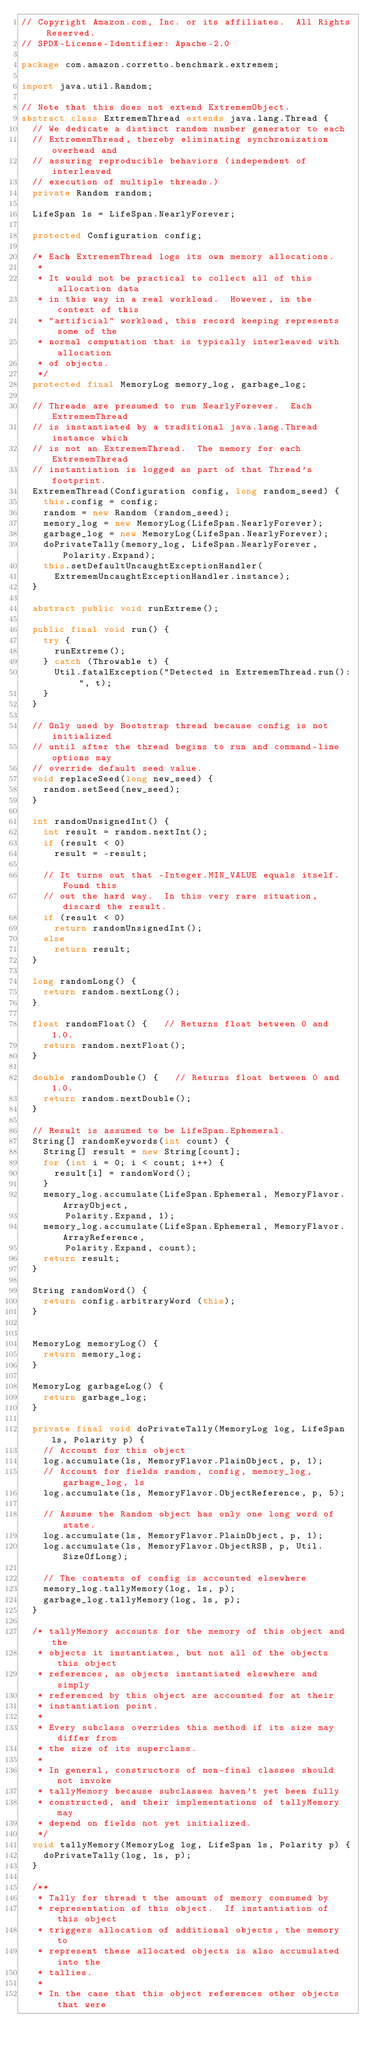Convert code to text. <code><loc_0><loc_0><loc_500><loc_500><_Java_>// Copyright Amazon.com, Inc. or its affiliates.  All Rights Reserved.
// SPDX-License-Identifier: Apache-2.0

package com.amazon.corretto.benchmark.extremem;

import java.util.Random;

// Note that this does not extend ExtrememObject.
abstract class ExtrememThread extends java.lang.Thread {
  // We dedicate a distinct random number generator to each
  // ExtrememThread, thereby eliminating synchronization overhead and
  // assuring reproducible behaviors (independent of interleaved
  // execution of multiple threads.)
  private Random random;

  LifeSpan ls = LifeSpan.NearlyForever;

  protected Configuration config;

  /* Each ExtrememThread logs its own memory allocations.
   *
   * It would not be practical to collect all of this allocation data
   * in this way in a real workload.  However, in the context of this
   * "artificial" workload, this record keeping represents some of the
   * normal computation that is typically interleaved with allocation
   * of objects.
   */
  protected final MemoryLog memory_log, garbage_log;

  // Threads are presumed to run NearlyForever.  Each ExtrememThread
  // is instantiated by a traditional java.lang.Thread instance which
  // is not an ExtrememThread.  The memory for each ExtrememThread
  // instantiation is logged as part of that Thread's footprint.
  ExtrememThread(Configuration config, long random_seed) {
    this.config = config;
    random = new Random (random_seed);
    memory_log = new MemoryLog(LifeSpan.NearlyForever);
    garbage_log = new MemoryLog(LifeSpan.NearlyForever);
    doPrivateTally(memory_log, LifeSpan.NearlyForever, Polarity.Expand);
    this.setDefaultUncaughtExceptionHandler(
      ExtrememUncaughtExceptionHandler.instance);
  }

  abstract public void runExtreme();

  public final void run() {
    try {
      runExtreme();
    } catch (Throwable t) {
      Util.fatalException("Detected in ExtrememThread.run(): ", t);
    }
  }

  // Only used by Bootstrap thread because config is not initialized
  // until after the thread begins to run and command-line options may
  // override default seed value.
  void replaceSeed(long new_seed) {
    random.setSeed(new_seed);
  }

  int randomUnsignedInt() {
    int result = random.nextInt();
    if (result < 0)
      result = -result;

    // It turns out that -Integer.MIN_VALUE equals itself.  Found this
    // out the hard way.  In this very rare situation, discard the result.
    if (result < 0)
      return randomUnsignedInt();
    else
      return result;
  }

  long randomLong() {
    return random.nextLong();
  }

  float randomFloat() {		// Returns float between 0 and 1.0.
    return random.nextFloat();
  }

  double randomDouble() {		// Returns float between 0 and 1.0.
    return random.nextDouble();
  }

  // Result is assumed to be LifeSpan.Ephemeral.
  String[] randomKeywords(int count) {
    String[] result = new String[count];
    for (int i = 0; i < count; i++) {
      result[i] = randomWord();
    }
    memory_log.accumulate(LifeSpan.Ephemeral, MemoryFlavor.ArrayObject,
			  Polarity.Expand, 1);
    memory_log.accumulate(LifeSpan.Ephemeral, MemoryFlavor.ArrayReference,
			  Polarity.Expand, count);
    return result;
  }

  String randomWord() {
    return config.arbitraryWord (this);
  }


  MemoryLog memoryLog() {
    return memory_log;
  }

  MemoryLog garbageLog() {
    return garbage_log;
  }

  private final void doPrivateTally(MemoryLog log, LifeSpan ls, Polarity p) {
    // Account for this object
    log.accumulate(ls, MemoryFlavor.PlainObject, p, 1);
    // Account for fields random, config, memory_log, garbage_log, ls
    log.accumulate(ls, MemoryFlavor.ObjectReference, p, 5);

    // Assume the Random object has only one long word of state.
    log.accumulate(ls, MemoryFlavor.PlainObject, p, 1);
    log.accumulate(ls, MemoryFlavor.ObjectRSB, p, Util.SizeOfLong);

    // The contents of config is accounted elsewhere
    memory_log.tallyMemory(log, ls, p);
    garbage_log.tallyMemory(log, ls, p);
  }

  /* tallyMemory accounts for the memory of this object and the
   * objects it instantiates, but not all of the objects this object
   * references, as objects instantiated elsewhere and simply
   * referenced by this object are accounted for at their
   * instantiation point.
   *
   * Every subclass overrides this method if its size may differ from
   * the size of its superclass.
   *
   * In general, constructors of non-final classes should not invoke
   * tallyMemory because subclasses haven't yet been fully
   * constructed, and their implementations of tallyMemory may 
   * depend on fields not yet initialized.
   */
  void tallyMemory(MemoryLog log, LifeSpan ls, Polarity p) {
    doPrivateTally(log, ls, p);
  }

  /**
   * Tally for thread t the amount of memory consumed by
   * representation of this object.  If instantiation of this object
   * triggers allocation of additional objects, the memory to
   * represent these allocated objects is also accumulated into the
   * tallies.
   *
   * In the case that this object references other objects that were</code> 